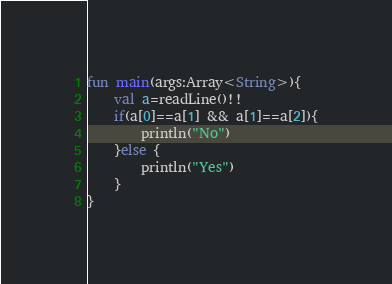<code> <loc_0><loc_0><loc_500><loc_500><_Kotlin_>fun main(args:Array<String>){
    val a=readLine()!!
    if(a[0]==a[1] && a[1]==a[2]){
        println("No")
    }else {
        println("Yes")
    }
}</code> 